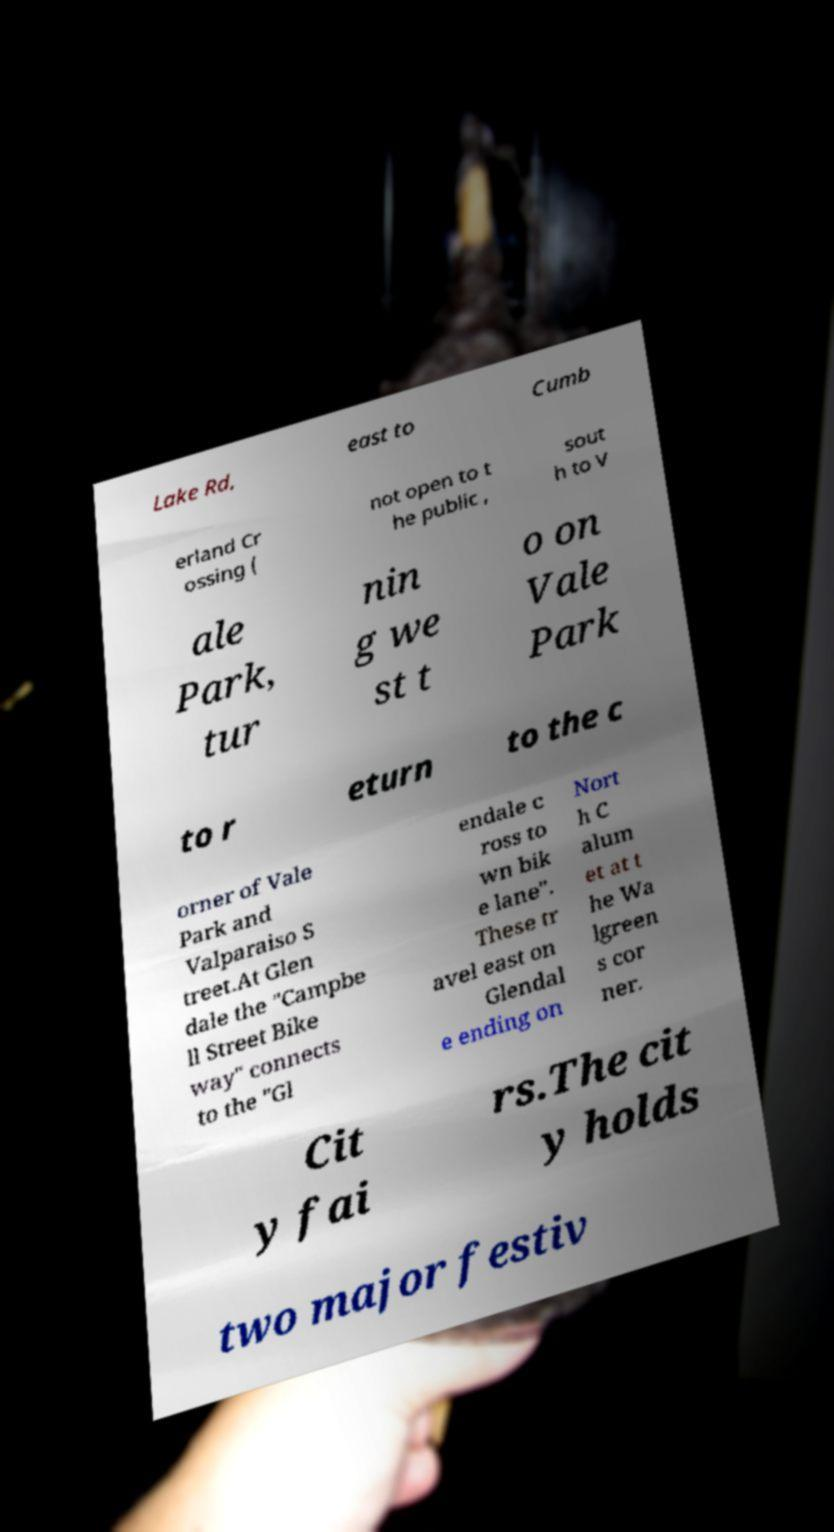There's text embedded in this image that I need extracted. Can you transcribe it verbatim? Lake Rd, east to Cumb erland Cr ossing ( not open to t he public , sout h to V ale Park, tur nin g we st t o on Vale Park to r eturn to the c orner of Vale Park and Valparaiso S treet.At Glen dale the "Campbe ll Street Bike way" connects to the "Gl endale c ross to wn bik e lane". These tr avel east on Glendal e ending on Nort h C alum et at t he Wa lgreen s cor ner. Cit y fai rs.The cit y holds two major festiv 